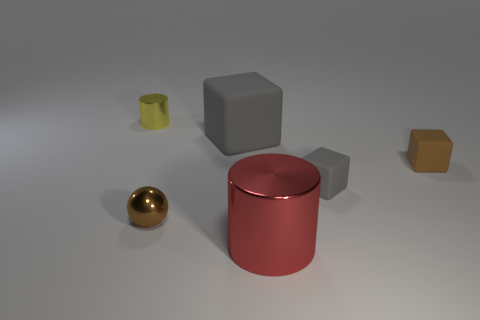There is a small object that is the same material as the tiny gray cube; what color is it?
Offer a very short reply. Brown. What size is the cylinder that is in front of the yellow metal cylinder?
Provide a short and direct response. Large. Does the small yellow cylinder have the same material as the brown ball?
Provide a succinct answer. Yes. Is there a rubber object to the left of the cylinder in front of the shiny cylinder that is left of the red shiny object?
Provide a succinct answer. Yes. The small shiny cylinder has what color?
Offer a terse response. Yellow. What is the color of the shiny cylinder that is the same size as the brown shiny ball?
Provide a succinct answer. Yellow. There is a big object that is behind the ball; is it the same shape as the small brown matte thing?
Provide a short and direct response. Yes. There is a matte cube that is in front of the tiny brown object that is on the right side of the cylinder that is to the right of the tiny metallic cylinder; what is its color?
Your answer should be very brief. Gray. Is there a gray cube?
Offer a very short reply. Yes. How many other objects are the same size as the brown rubber thing?
Provide a succinct answer. 3. 